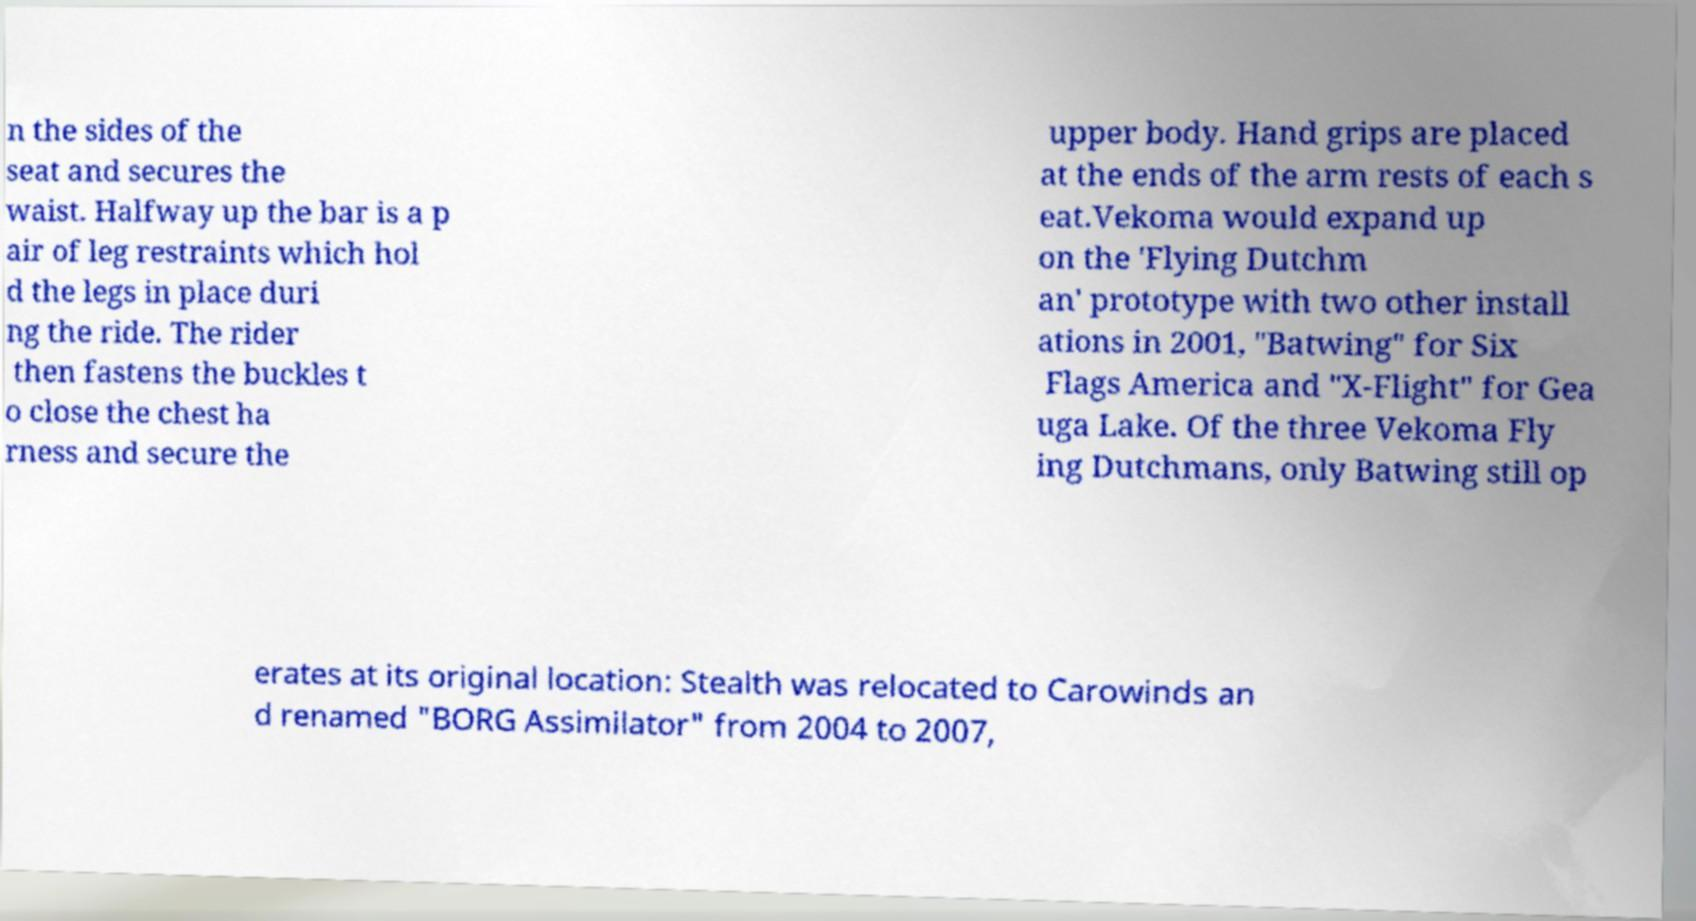Could you extract and type out the text from this image? n the sides of the seat and secures the waist. Halfway up the bar is a p air of leg restraints which hol d the legs in place duri ng the ride. The rider then fastens the buckles t o close the chest ha rness and secure the upper body. Hand grips are placed at the ends of the arm rests of each s eat.Vekoma would expand up on the 'Flying Dutchm an' prototype with two other install ations in 2001, "Batwing" for Six Flags America and "X-Flight" for Gea uga Lake. Of the three Vekoma Fly ing Dutchmans, only Batwing still op erates at its original location: Stealth was relocated to Carowinds an d renamed "BORG Assimilator" from 2004 to 2007, 